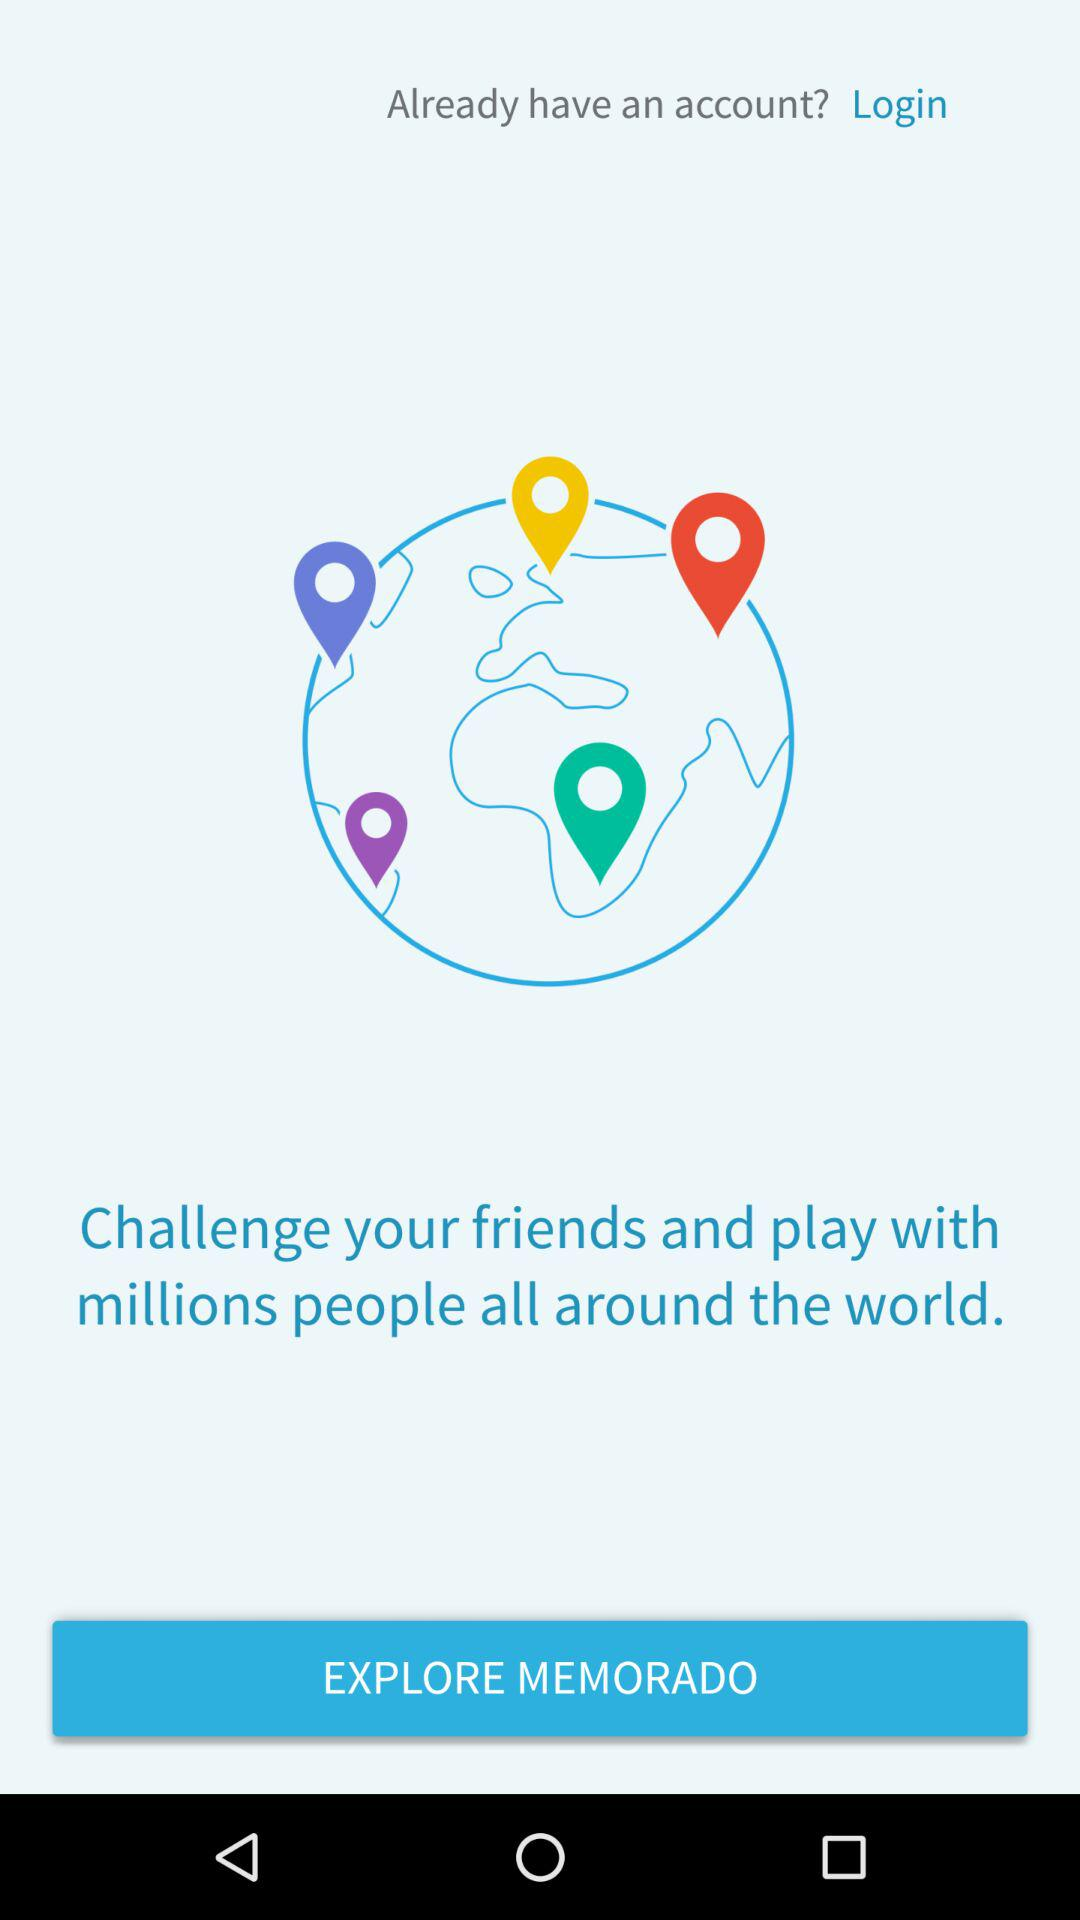What is the name of the application? The name of the application is "Memorado". 